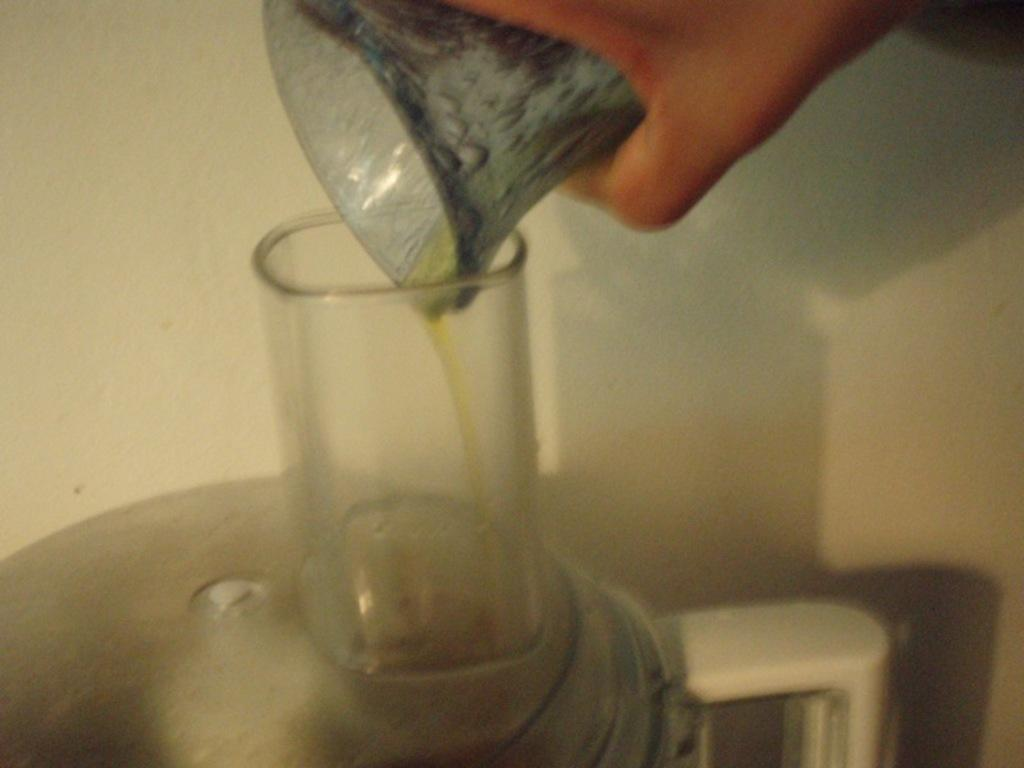What is the person holding in the image? There is a hand of a person holding an object in the image. What other objects can be seen in the image? There is a jar and a glass in the image. What is visible in the background of the image? There is a wall in the background of the image. What type of yarn is being used to play the guitar in the image? There is no yarn or guitar present in the image. 